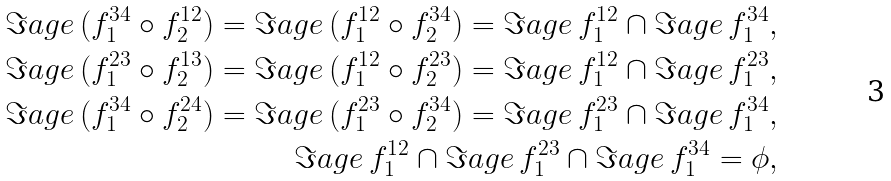<formula> <loc_0><loc_0><loc_500><loc_500>\Im a g e \, ( f _ { 1 } ^ { 3 4 } \circ f _ { 2 } ^ { 1 2 } ) = \Im a g e \, ( f _ { 1 } ^ { 1 2 } \circ f _ { 2 } ^ { 3 4 } ) = \Im a g e \, f _ { 1 } ^ { 1 2 } \cap \Im a g e \, f _ { 1 } ^ { 3 4 } , \\ \Im a g e \, ( f _ { 1 } ^ { 2 3 } \circ f _ { 2 } ^ { 1 3 } ) = \Im a g e \, ( f _ { 1 } ^ { 1 2 } \circ f _ { 2 } ^ { 2 3 } ) = \Im a g e \, f _ { 1 } ^ { 1 2 } \cap \Im a g e \, f _ { 1 } ^ { 2 3 } , \\ \Im a g e \, ( f _ { 1 } ^ { 3 4 } \circ f _ { 2 } ^ { 2 4 } ) = \Im a g e \, ( f _ { 1 } ^ { 2 3 } \circ f _ { 2 } ^ { 3 4 } ) = \Im a g e \, f _ { 1 } ^ { 2 3 } \cap \Im a g e \, f _ { 1 } ^ { 3 4 } , \\ \Im a g e \, f _ { 1 } ^ { 1 2 } \cap \Im a g e \, f _ { 1 } ^ { 2 3 } \cap \Im a g e \, f _ { 1 } ^ { 3 4 } = \phi ,</formula> 